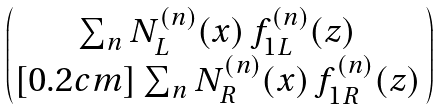Convert formula to latex. <formula><loc_0><loc_0><loc_500><loc_500>\begin{pmatrix} \sum _ { n } N _ { L } ^ { ( n ) } ( x ) \, f _ { 1 L } ^ { ( n ) } ( z ) \, \\ [ 0 . 2 c m ] \sum _ { n } N _ { R } ^ { ( n ) } ( x ) \, f _ { 1 R } ^ { ( n ) } ( z ) \, \end{pmatrix}</formula> 